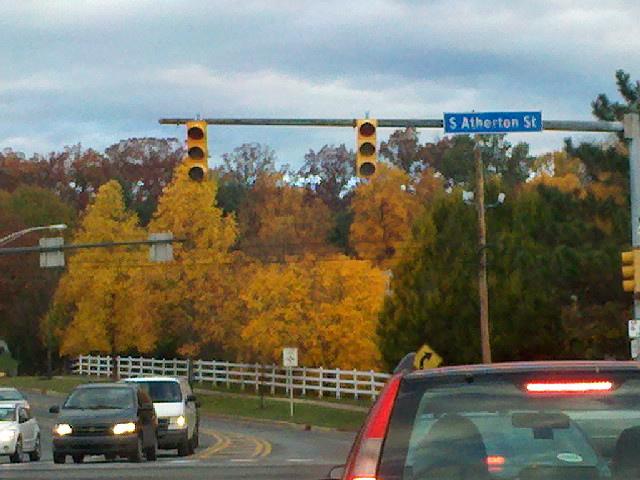What is the street name on the sign?
Write a very short answer. S atherton st. What color is the street sign?
Write a very short answer. Blue. Are the traffic lights out?
Give a very brief answer. Yes. 